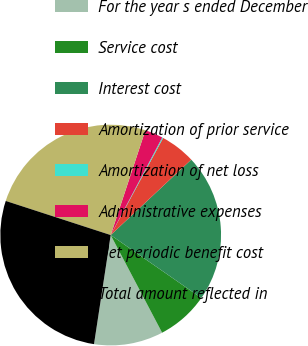Convert chart to OTSL. <chart><loc_0><loc_0><loc_500><loc_500><pie_chart><fcel>For the year s ended December<fcel>Service cost<fcel>Interest cost<fcel>Amortization of prior service<fcel>Amortization of net loss<fcel>Administrative expenses<fcel>Net periodic benefit cost<fcel>Total amount reflected in<nl><fcel>10.13%<fcel>7.63%<fcel>21.64%<fcel>5.14%<fcel>0.15%<fcel>2.64%<fcel>25.09%<fcel>27.59%<nl></chart> 